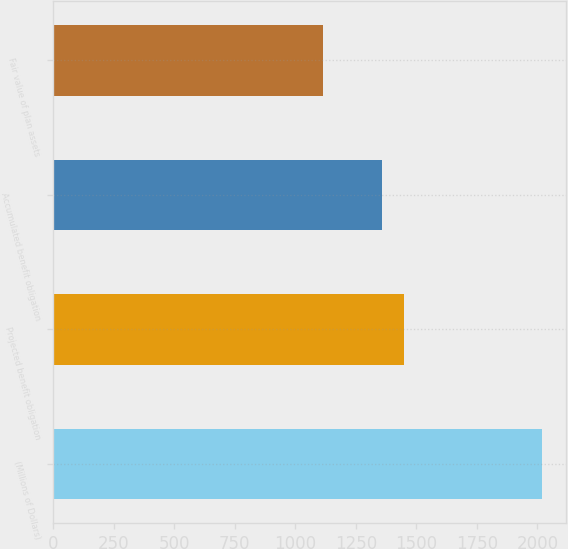Convert chart. <chart><loc_0><loc_0><loc_500><loc_500><bar_chart><fcel>(Millions of Dollars)<fcel>Projected benefit obligation<fcel>Accumulated benefit obligation<fcel>Fair value of plan assets<nl><fcel>2017<fcel>1448.69<fcel>1358.4<fcel>1114.1<nl></chart> 